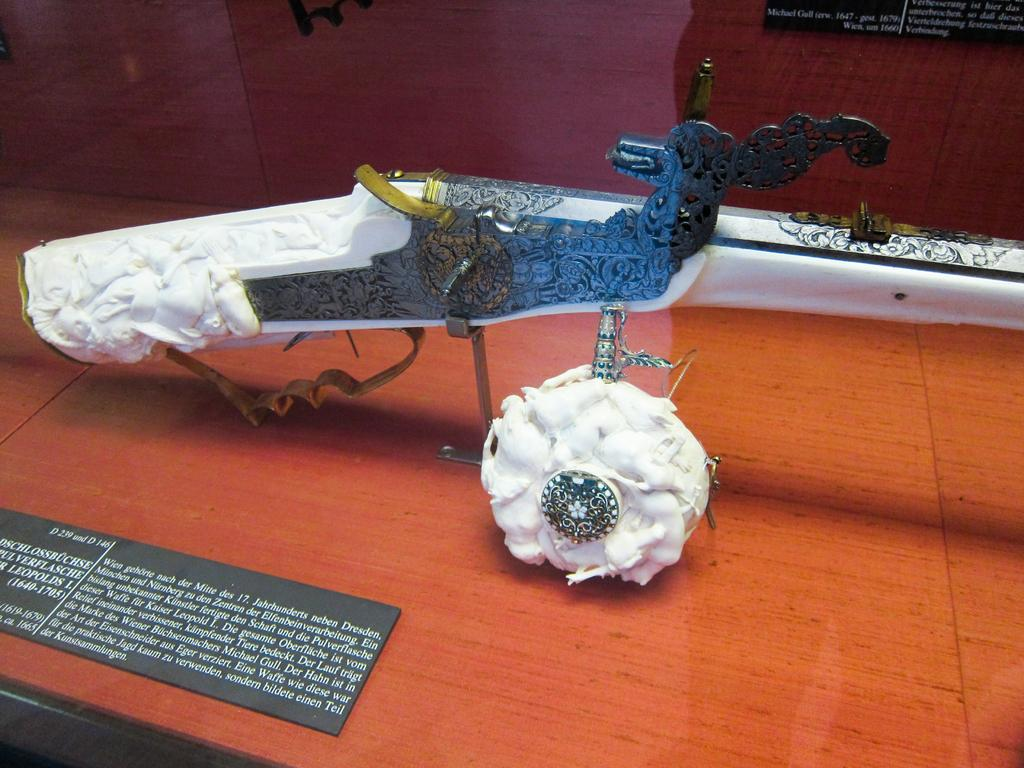What is one of the main objects in the image? There is a mirror in the image. What can be seen in the background of the image? There are two white color objects in the background of the image. What is the color and type of the board in the image? There is a black color board in the image. What is written or printed on the black color board? There is text printed on the black color board. Where can someone get a haircut in the image? There is no indication of a haircut or a place to get one in the image. 